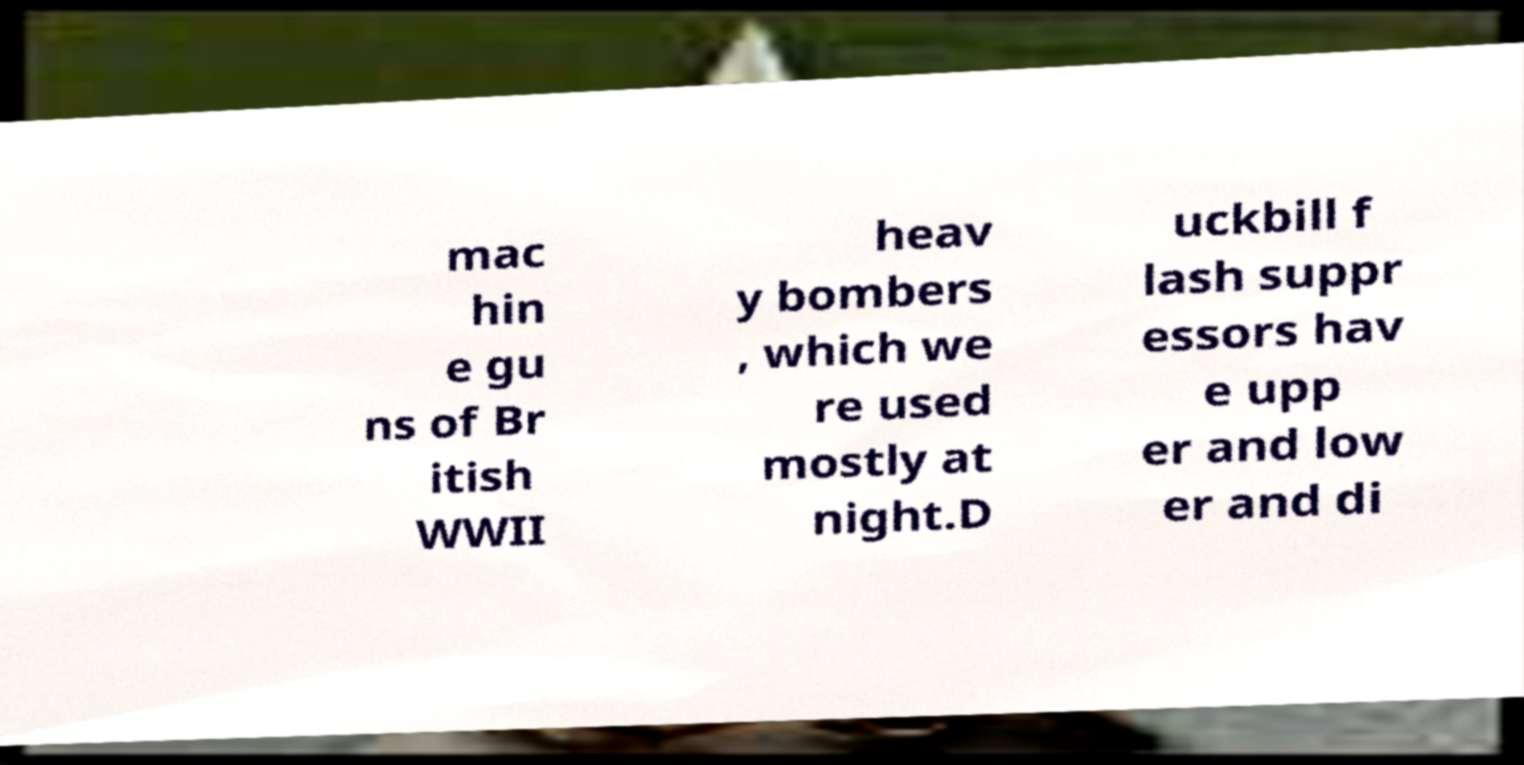I need the written content from this picture converted into text. Can you do that? mac hin e gu ns of Br itish WWII heav y bombers , which we re used mostly at night.D uckbill f lash suppr essors hav e upp er and low er and di 